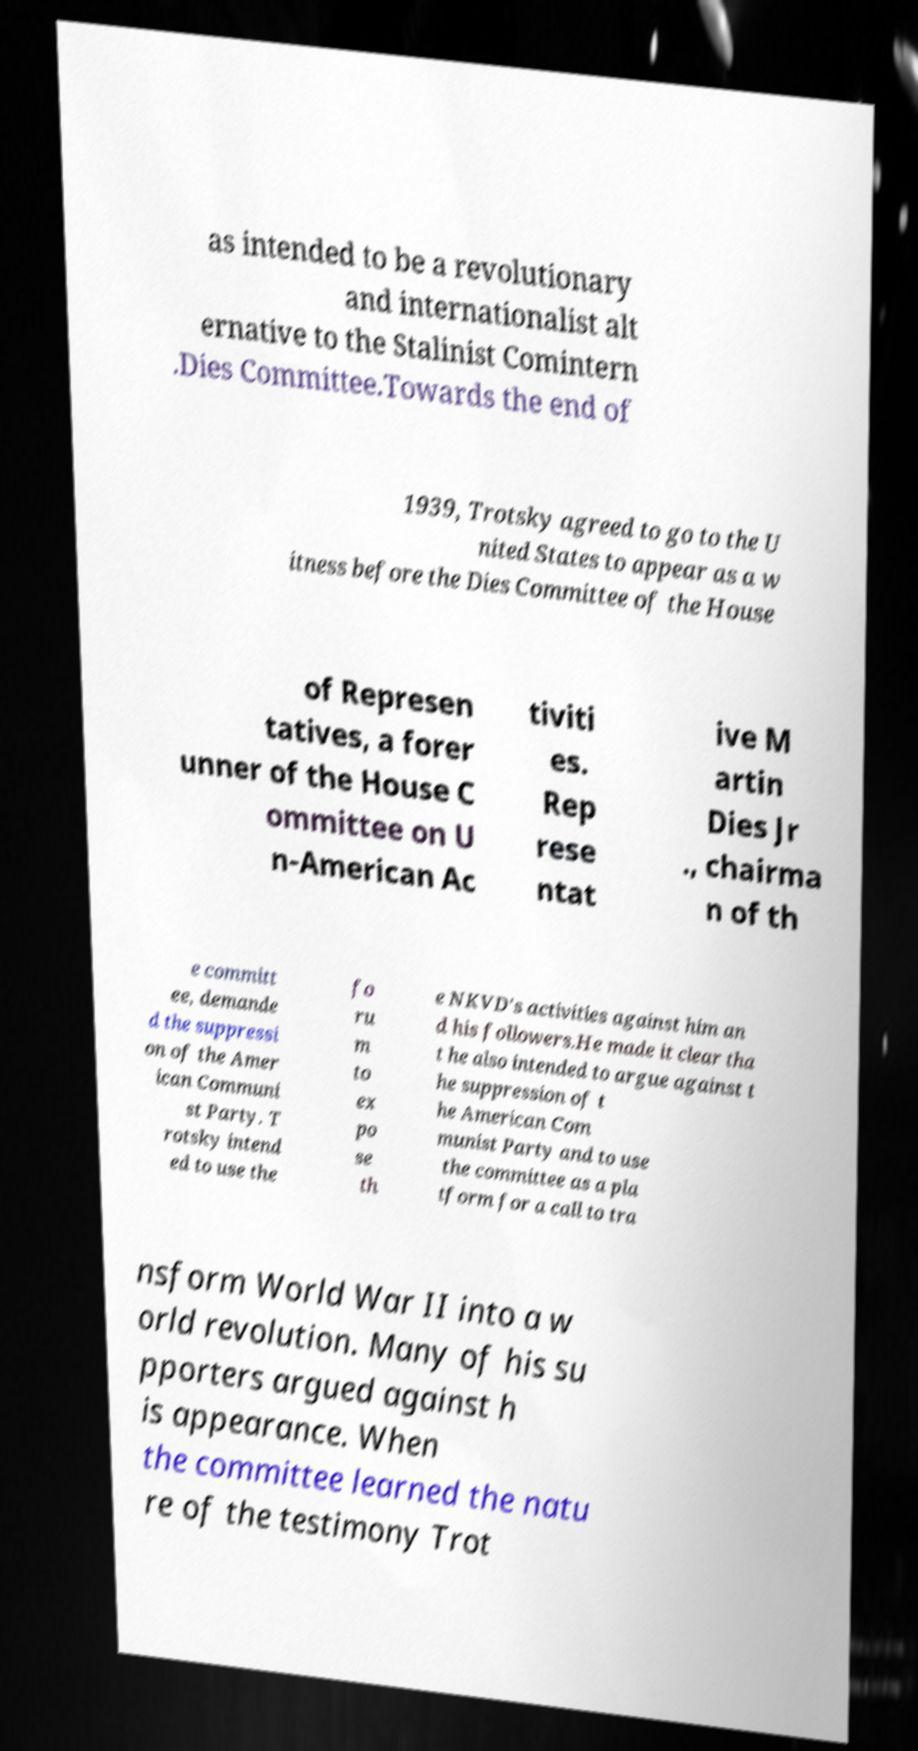Can you accurately transcribe the text from the provided image for me? as intended to be a revolutionary and internationalist alt ernative to the Stalinist Comintern .Dies Committee.Towards the end of 1939, Trotsky agreed to go to the U nited States to appear as a w itness before the Dies Committee of the House of Represen tatives, a forer unner of the House C ommittee on U n-American Ac tiviti es. Rep rese ntat ive M artin Dies Jr ., chairma n of th e committ ee, demande d the suppressi on of the Amer ican Communi st Party. T rotsky intend ed to use the fo ru m to ex po se th e NKVD's activities against him an d his followers.He made it clear tha t he also intended to argue against t he suppression of t he American Com munist Party and to use the committee as a pla tform for a call to tra nsform World War II into a w orld revolution. Many of his su pporters argued against h is appearance. When the committee learned the natu re of the testimony Trot 